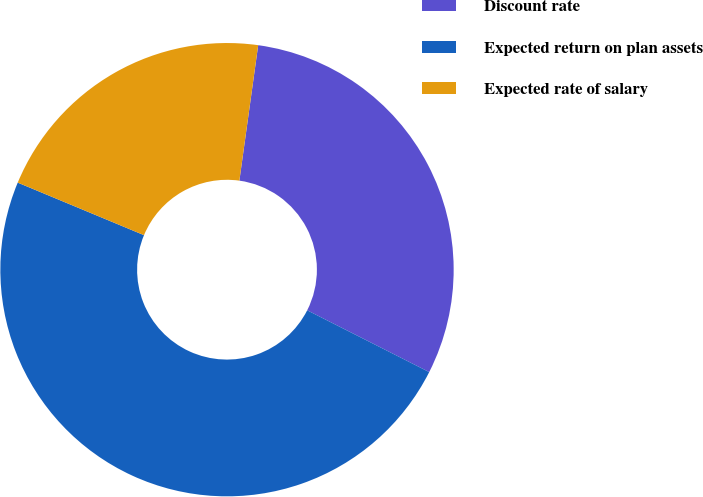Convert chart. <chart><loc_0><loc_0><loc_500><loc_500><pie_chart><fcel>Discount rate<fcel>Expected return on plan assets<fcel>Expected rate of salary<nl><fcel>30.26%<fcel>48.81%<fcel>20.92%<nl></chart> 